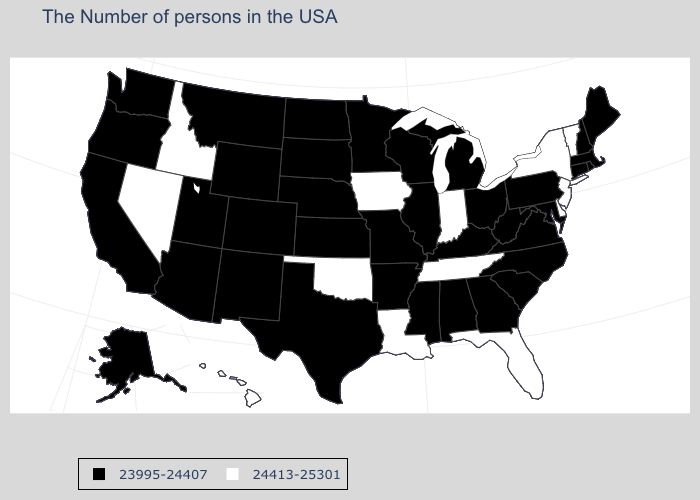Is the legend a continuous bar?
Short answer required. No. Among the states that border Washington , does Oregon have the lowest value?
Give a very brief answer. Yes. What is the value of Wyoming?
Keep it brief. 23995-24407. Name the states that have a value in the range 23995-24407?
Answer briefly. Maine, Massachusetts, Rhode Island, New Hampshire, Connecticut, Maryland, Pennsylvania, Virginia, North Carolina, South Carolina, West Virginia, Ohio, Georgia, Michigan, Kentucky, Alabama, Wisconsin, Illinois, Mississippi, Missouri, Arkansas, Minnesota, Kansas, Nebraska, Texas, South Dakota, North Dakota, Wyoming, Colorado, New Mexico, Utah, Montana, Arizona, California, Washington, Oregon, Alaska. Name the states that have a value in the range 24413-25301?
Write a very short answer. Vermont, New York, New Jersey, Delaware, Florida, Indiana, Tennessee, Louisiana, Iowa, Oklahoma, Idaho, Nevada, Hawaii. Which states have the lowest value in the Northeast?
Give a very brief answer. Maine, Massachusetts, Rhode Island, New Hampshire, Connecticut, Pennsylvania. Does Arkansas have the highest value in the USA?
Write a very short answer. No. Name the states that have a value in the range 24413-25301?
Give a very brief answer. Vermont, New York, New Jersey, Delaware, Florida, Indiana, Tennessee, Louisiana, Iowa, Oklahoma, Idaho, Nevada, Hawaii. Among the states that border New Jersey , which have the highest value?
Keep it brief. New York, Delaware. Does the first symbol in the legend represent the smallest category?
Give a very brief answer. Yes. Among the states that border Vermont , which have the highest value?
Be succinct. New York. Name the states that have a value in the range 23995-24407?
Be succinct. Maine, Massachusetts, Rhode Island, New Hampshire, Connecticut, Maryland, Pennsylvania, Virginia, North Carolina, South Carolina, West Virginia, Ohio, Georgia, Michigan, Kentucky, Alabama, Wisconsin, Illinois, Mississippi, Missouri, Arkansas, Minnesota, Kansas, Nebraska, Texas, South Dakota, North Dakota, Wyoming, Colorado, New Mexico, Utah, Montana, Arizona, California, Washington, Oregon, Alaska. Name the states that have a value in the range 23995-24407?
Keep it brief. Maine, Massachusetts, Rhode Island, New Hampshire, Connecticut, Maryland, Pennsylvania, Virginia, North Carolina, South Carolina, West Virginia, Ohio, Georgia, Michigan, Kentucky, Alabama, Wisconsin, Illinois, Mississippi, Missouri, Arkansas, Minnesota, Kansas, Nebraska, Texas, South Dakota, North Dakota, Wyoming, Colorado, New Mexico, Utah, Montana, Arizona, California, Washington, Oregon, Alaska. What is the highest value in the USA?
Give a very brief answer. 24413-25301. Does the map have missing data?
Concise answer only. No. 